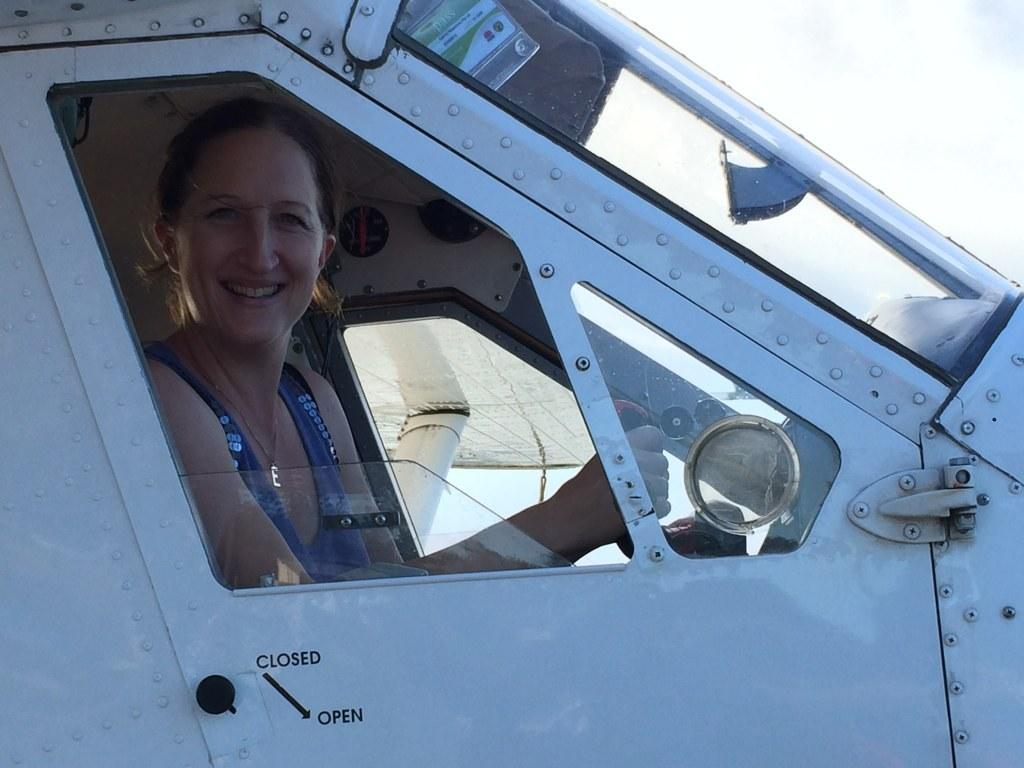Who is present in the image? There is a woman in the image. What is the woman doing in the image? The woman is sitting in a vehicle. What is the woman's facial expression in the image? The woman is smiling. What part of the vehicle can be seen in the image? There is a door of a vehicle visible in the image. What is visible in the background of the image? The sky is visible in the background of the image. What type of pipe is the woman holding in the image? There is no pipe present in the image; the woman is sitting in a vehicle and smiling. 